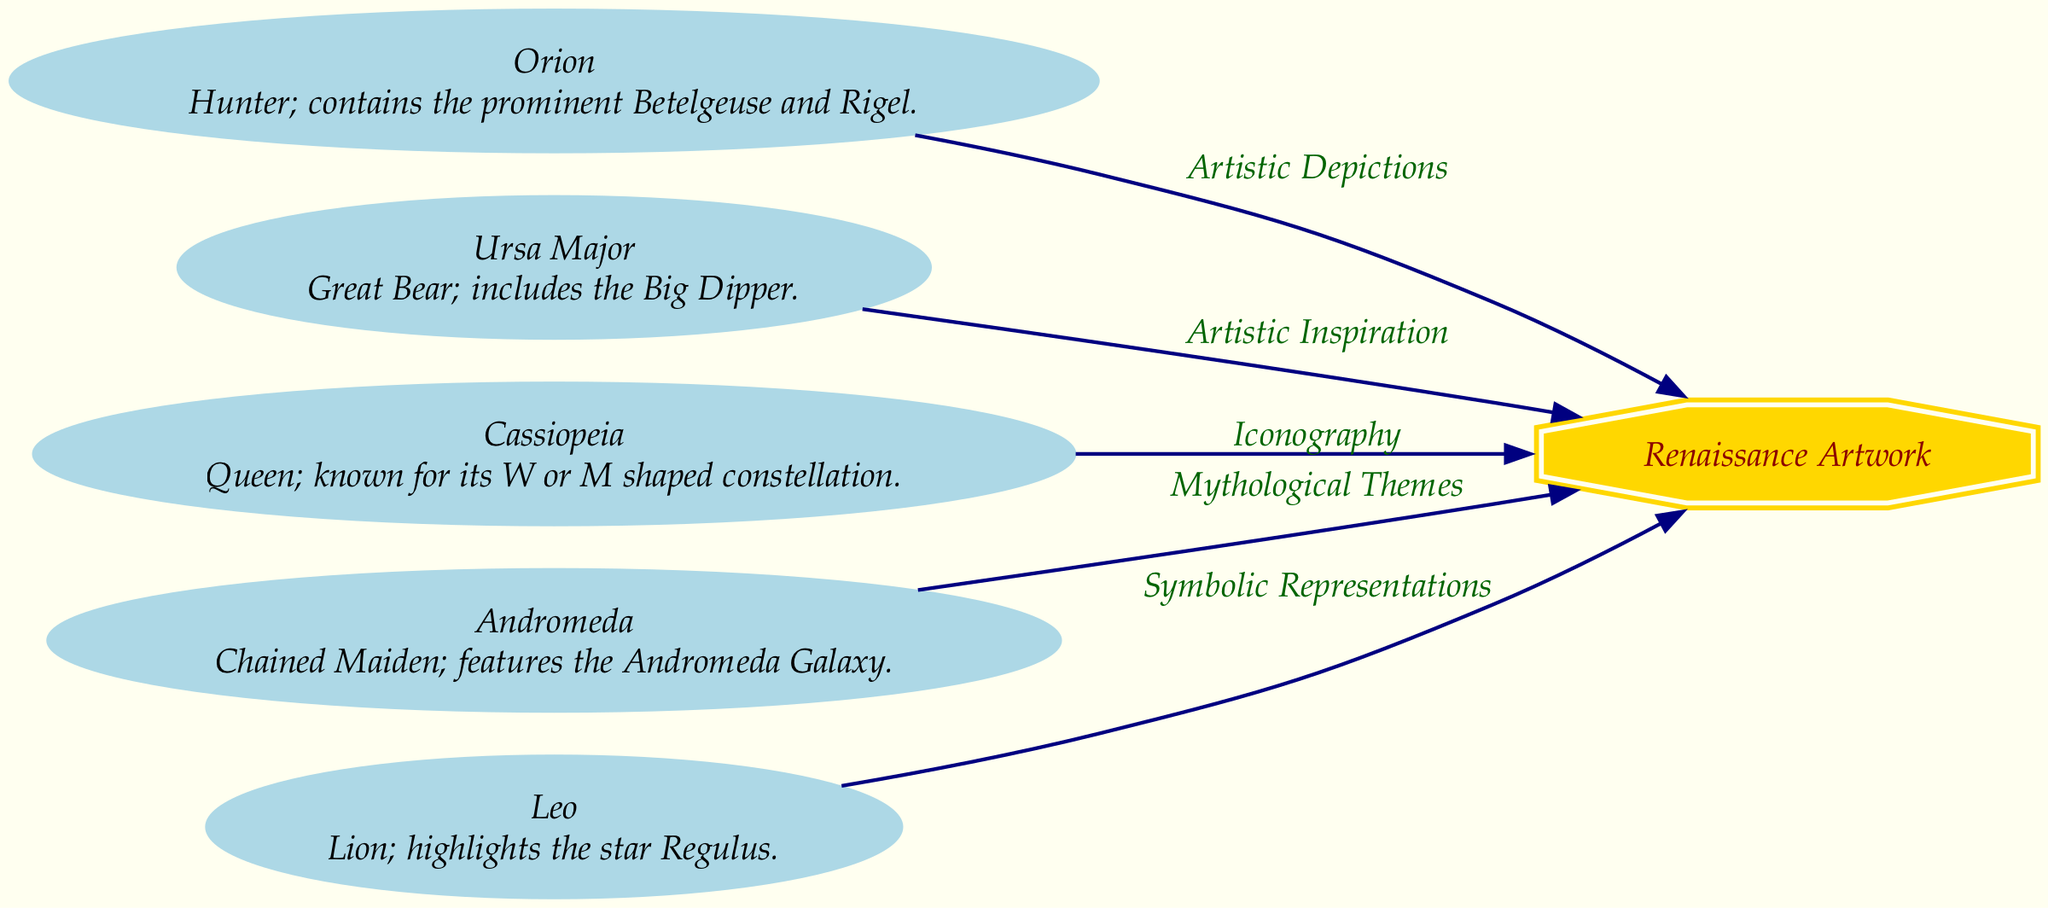What is the central theme of the diagram? The diagram centers around the artistic representations of various constellations through the lens of Renaissance art. These connections illustrate how celestial bodies influenced and inspired artists during that period.
Answer: Renaissance artwork How many constellations are depicted in the diagram? By counting the nodes labeled as constellations in the diagram, we see that there are five constellations, which include Orion, Ursa Major, Cassiopeia, Andromeda, and Leo.
Answer: 5 Which constellation is linked to mythological themes? The Andromeda constellation is specifically associated with mythological themes, highlighting its significance in both astronomy and storytelling throughout history.
Answer: Andromeda What shape is the node representing Renaissance Artwork? The Renaissance Artwork node is represented in the diagram as a double octagon, distinguishing it from the other elliptical nodes representing constellations.
Answer: double octagon What is the relationship between Orion and Renaissance Artwork? The relationship indicated in the diagram shows that Orion is connected to Renaissance Artwork through artistic depictions, suggesting that Orion served as a notable subject or influence in Renaissance art.
Answer: Artistic Depictions Which constellation is described as having an 'iconography'? The diagram indicates that Cassiopeia has a connection noted for its distinctive iconography, particularly recognized for the distinctive W or M shape formed by its stars.
Answer: Cassiopeia What is the prominent star in the Leo constellation? The diagram specifies that the constellation Leo includes the prominent star Regulus, highlighting its importance among the stars that define this zodiacal constellation.
Answer: Regulus How many edges are connected to the Renaissance Artwork node? The Renaissance Artwork node connects to all five constellations noted in the diagram, resulting in a total of five edges, each representing a different thematic connection from the constellations to the artwork.
Answer: 5 Which constellation includes the Big Dipper? According to the diagram, Ursa Major is the constellation that encompasses the Big Dipper, which is one of its most recognizable asterisms in the night sky.
Answer: Ursa Major 